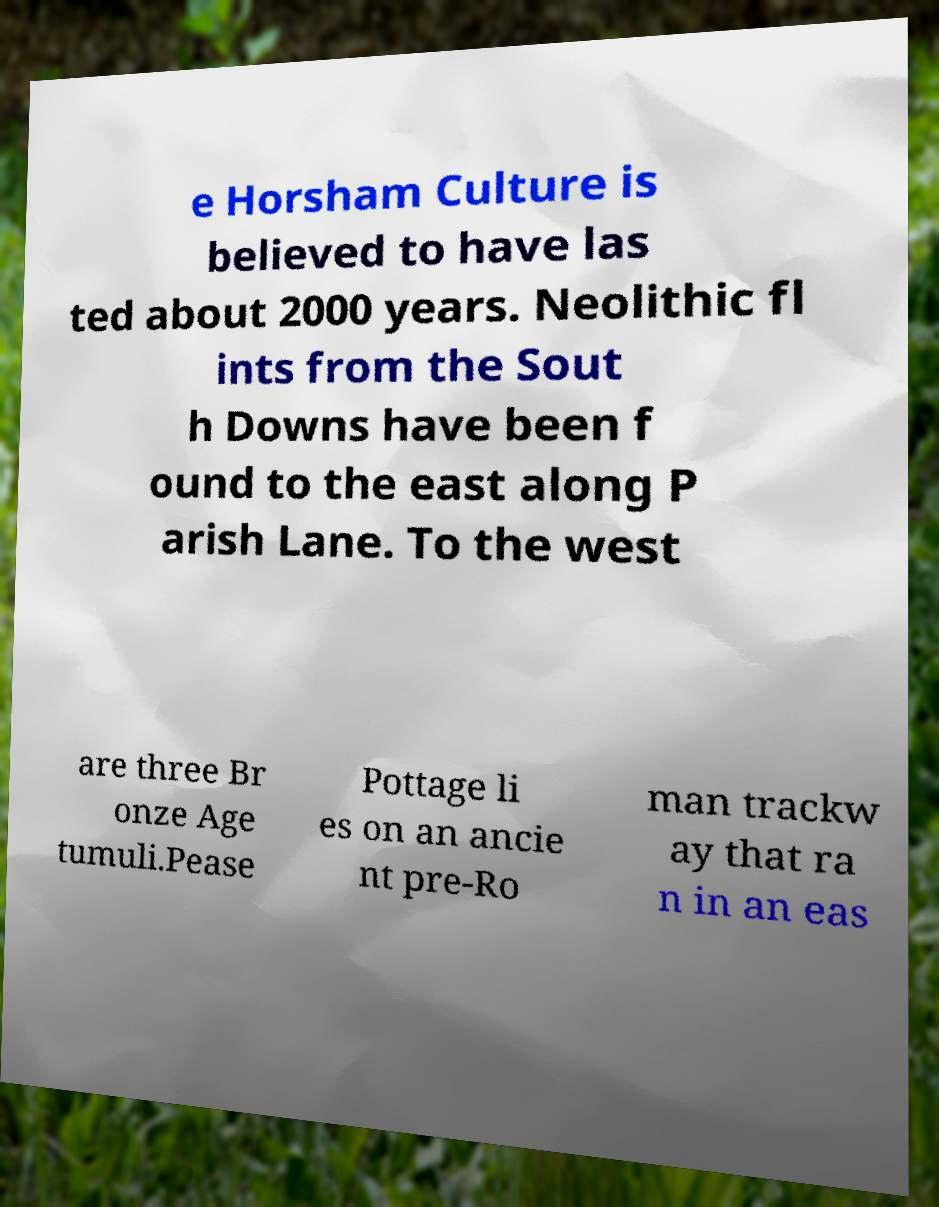Please identify and transcribe the text found in this image. e Horsham Culture is believed to have las ted about 2000 years. Neolithic fl ints from the Sout h Downs have been f ound to the east along P arish Lane. To the west are three Br onze Age tumuli.Pease Pottage li es on an ancie nt pre-Ro man trackw ay that ra n in an eas 